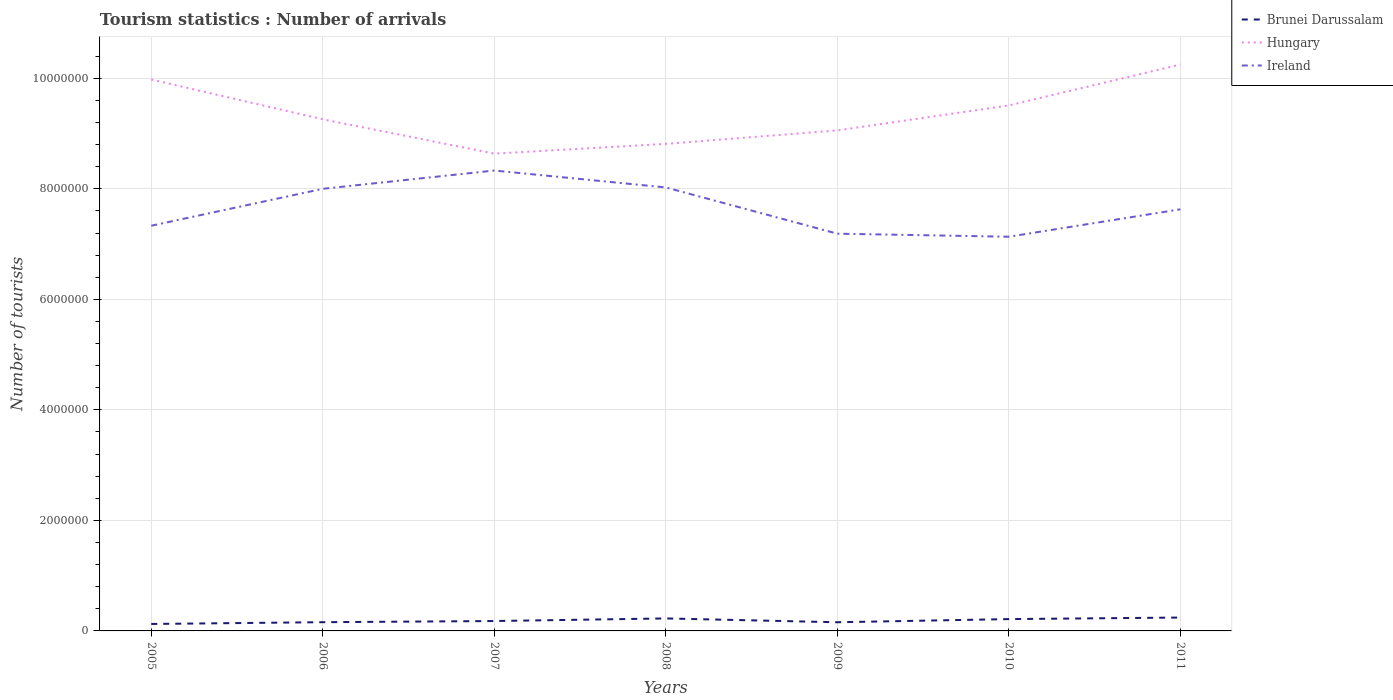Does the line corresponding to Ireland intersect with the line corresponding to Hungary?
Keep it short and to the point. No. Is the number of lines equal to the number of legend labels?
Make the answer very short. Yes. Across all years, what is the maximum number of tourist arrivals in Ireland?
Make the answer very short. 7.13e+06. What is the total number of tourist arrivals in Brunei Darussalam in the graph?
Provide a succinct answer. -1.00e+05. What is the difference between the highest and the second highest number of tourist arrivals in Brunei Darussalam?
Your answer should be very brief. 1.16e+05. What is the difference between the highest and the lowest number of tourist arrivals in Hungary?
Your answer should be very brief. 3. How many lines are there?
Ensure brevity in your answer.  3. What is the difference between two consecutive major ticks on the Y-axis?
Offer a very short reply. 2.00e+06. Does the graph contain any zero values?
Your answer should be very brief. No. Does the graph contain grids?
Give a very brief answer. Yes. Where does the legend appear in the graph?
Your response must be concise. Top right. How many legend labels are there?
Your answer should be very brief. 3. How are the legend labels stacked?
Your response must be concise. Vertical. What is the title of the graph?
Your response must be concise. Tourism statistics : Number of arrivals. What is the label or title of the Y-axis?
Offer a terse response. Number of tourists. What is the Number of tourists of Brunei Darussalam in 2005?
Offer a very short reply. 1.26e+05. What is the Number of tourists in Hungary in 2005?
Your answer should be very brief. 9.98e+06. What is the Number of tourists of Ireland in 2005?
Ensure brevity in your answer.  7.33e+06. What is the Number of tourists in Brunei Darussalam in 2006?
Your response must be concise. 1.58e+05. What is the Number of tourists of Hungary in 2006?
Your answer should be compact. 9.26e+06. What is the Number of tourists of Ireland in 2006?
Provide a short and direct response. 8.00e+06. What is the Number of tourists in Brunei Darussalam in 2007?
Provide a short and direct response. 1.79e+05. What is the Number of tourists of Hungary in 2007?
Ensure brevity in your answer.  8.64e+06. What is the Number of tourists of Ireland in 2007?
Provide a succinct answer. 8.33e+06. What is the Number of tourists of Brunei Darussalam in 2008?
Give a very brief answer. 2.26e+05. What is the Number of tourists in Hungary in 2008?
Keep it short and to the point. 8.81e+06. What is the Number of tourists in Ireland in 2008?
Provide a succinct answer. 8.03e+06. What is the Number of tourists in Brunei Darussalam in 2009?
Offer a very short reply. 1.57e+05. What is the Number of tourists of Hungary in 2009?
Make the answer very short. 9.06e+06. What is the Number of tourists of Ireland in 2009?
Make the answer very short. 7.19e+06. What is the Number of tourists of Brunei Darussalam in 2010?
Provide a short and direct response. 2.14e+05. What is the Number of tourists in Hungary in 2010?
Provide a succinct answer. 9.51e+06. What is the Number of tourists in Ireland in 2010?
Your answer should be compact. 7.13e+06. What is the Number of tourists in Brunei Darussalam in 2011?
Ensure brevity in your answer.  2.42e+05. What is the Number of tourists of Hungary in 2011?
Provide a short and direct response. 1.02e+07. What is the Number of tourists in Ireland in 2011?
Provide a succinct answer. 7.63e+06. Across all years, what is the maximum Number of tourists of Brunei Darussalam?
Keep it short and to the point. 2.42e+05. Across all years, what is the maximum Number of tourists in Hungary?
Ensure brevity in your answer.  1.02e+07. Across all years, what is the maximum Number of tourists of Ireland?
Ensure brevity in your answer.  8.33e+06. Across all years, what is the minimum Number of tourists of Brunei Darussalam?
Offer a terse response. 1.26e+05. Across all years, what is the minimum Number of tourists in Hungary?
Keep it short and to the point. 8.64e+06. Across all years, what is the minimum Number of tourists in Ireland?
Your response must be concise. 7.13e+06. What is the total Number of tourists in Brunei Darussalam in the graph?
Give a very brief answer. 1.30e+06. What is the total Number of tourists in Hungary in the graph?
Your answer should be compact. 6.55e+07. What is the total Number of tourists in Ireland in the graph?
Your response must be concise. 5.36e+07. What is the difference between the Number of tourists of Brunei Darussalam in 2005 and that in 2006?
Make the answer very short. -3.20e+04. What is the difference between the Number of tourists of Hungary in 2005 and that in 2006?
Provide a short and direct response. 7.20e+05. What is the difference between the Number of tourists in Ireland in 2005 and that in 2006?
Ensure brevity in your answer.  -6.68e+05. What is the difference between the Number of tourists of Brunei Darussalam in 2005 and that in 2007?
Offer a terse response. -5.30e+04. What is the difference between the Number of tourists of Hungary in 2005 and that in 2007?
Your answer should be very brief. 1.34e+06. What is the difference between the Number of tourists in Ireland in 2005 and that in 2007?
Make the answer very short. -9.99e+05. What is the difference between the Number of tourists of Brunei Darussalam in 2005 and that in 2008?
Give a very brief answer. -1.00e+05. What is the difference between the Number of tourists of Hungary in 2005 and that in 2008?
Your answer should be very brief. 1.16e+06. What is the difference between the Number of tourists of Ireland in 2005 and that in 2008?
Make the answer very short. -6.93e+05. What is the difference between the Number of tourists in Brunei Darussalam in 2005 and that in 2009?
Provide a succinct answer. -3.10e+04. What is the difference between the Number of tourists in Hungary in 2005 and that in 2009?
Your answer should be compact. 9.21e+05. What is the difference between the Number of tourists in Ireland in 2005 and that in 2009?
Offer a terse response. 1.44e+05. What is the difference between the Number of tourists in Brunei Darussalam in 2005 and that in 2010?
Give a very brief answer. -8.80e+04. What is the difference between the Number of tourists in Hungary in 2005 and that in 2010?
Your answer should be compact. 4.69e+05. What is the difference between the Number of tourists of Ireland in 2005 and that in 2010?
Your response must be concise. 1.99e+05. What is the difference between the Number of tourists in Brunei Darussalam in 2005 and that in 2011?
Ensure brevity in your answer.  -1.16e+05. What is the difference between the Number of tourists in Hungary in 2005 and that in 2011?
Ensure brevity in your answer.  -2.71e+05. What is the difference between the Number of tourists in Ireland in 2005 and that in 2011?
Ensure brevity in your answer.  -2.97e+05. What is the difference between the Number of tourists of Brunei Darussalam in 2006 and that in 2007?
Keep it short and to the point. -2.10e+04. What is the difference between the Number of tourists of Hungary in 2006 and that in 2007?
Keep it short and to the point. 6.21e+05. What is the difference between the Number of tourists of Ireland in 2006 and that in 2007?
Keep it short and to the point. -3.31e+05. What is the difference between the Number of tourists in Brunei Darussalam in 2006 and that in 2008?
Offer a terse response. -6.80e+04. What is the difference between the Number of tourists of Hungary in 2006 and that in 2008?
Your answer should be compact. 4.45e+05. What is the difference between the Number of tourists in Ireland in 2006 and that in 2008?
Provide a succinct answer. -2.50e+04. What is the difference between the Number of tourists in Brunei Darussalam in 2006 and that in 2009?
Keep it short and to the point. 1000. What is the difference between the Number of tourists in Hungary in 2006 and that in 2009?
Keep it short and to the point. 2.01e+05. What is the difference between the Number of tourists of Ireland in 2006 and that in 2009?
Offer a terse response. 8.12e+05. What is the difference between the Number of tourists in Brunei Darussalam in 2006 and that in 2010?
Make the answer very short. -5.60e+04. What is the difference between the Number of tourists of Hungary in 2006 and that in 2010?
Give a very brief answer. -2.51e+05. What is the difference between the Number of tourists of Ireland in 2006 and that in 2010?
Ensure brevity in your answer.  8.67e+05. What is the difference between the Number of tourists in Brunei Darussalam in 2006 and that in 2011?
Give a very brief answer. -8.40e+04. What is the difference between the Number of tourists of Hungary in 2006 and that in 2011?
Your answer should be compact. -9.91e+05. What is the difference between the Number of tourists in Ireland in 2006 and that in 2011?
Give a very brief answer. 3.71e+05. What is the difference between the Number of tourists of Brunei Darussalam in 2007 and that in 2008?
Provide a succinct answer. -4.70e+04. What is the difference between the Number of tourists of Hungary in 2007 and that in 2008?
Keep it short and to the point. -1.76e+05. What is the difference between the Number of tourists in Ireland in 2007 and that in 2008?
Provide a succinct answer. 3.06e+05. What is the difference between the Number of tourists of Brunei Darussalam in 2007 and that in 2009?
Ensure brevity in your answer.  2.20e+04. What is the difference between the Number of tourists in Hungary in 2007 and that in 2009?
Offer a terse response. -4.20e+05. What is the difference between the Number of tourists of Ireland in 2007 and that in 2009?
Offer a very short reply. 1.14e+06. What is the difference between the Number of tourists of Brunei Darussalam in 2007 and that in 2010?
Provide a succinct answer. -3.50e+04. What is the difference between the Number of tourists in Hungary in 2007 and that in 2010?
Your response must be concise. -8.72e+05. What is the difference between the Number of tourists in Ireland in 2007 and that in 2010?
Keep it short and to the point. 1.20e+06. What is the difference between the Number of tourists in Brunei Darussalam in 2007 and that in 2011?
Make the answer very short. -6.30e+04. What is the difference between the Number of tourists in Hungary in 2007 and that in 2011?
Your answer should be very brief. -1.61e+06. What is the difference between the Number of tourists in Ireland in 2007 and that in 2011?
Keep it short and to the point. 7.02e+05. What is the difference between the Number of tourists in Brunei Darussalam in 2008 and that in 2009?
Keep it short and to the point. 6.90e+04. What is the difference between the Number of tourists in Hungary in 2008 and that in 2009?
Make the answer very short. -2.44e+05. What is the difference between the Number of tourists of Ireland in 2008 and that in 2009?
Your response must be concise. 8.37e+05. What is the difference between the Number of tourists in Brunei Darussalam in 2008 and that in 2010?
Your answer should be very brief. 1.20e+04. What is the difference between the Number of tourists in Hungary in 2008 and that in 2010?
Provide a short and direct response. -6.96e+05. What is the difference between the Number of tourists in Ireland in 2008 and that in 2010?
Offer a very short reply. 8.92e+05. What is the difference between the Number of tourists of Brunei Darussalam in 2008 and that in 2011?
Ensure brevity in your answer.  -1.60e+04. What is the difference between the Number of tourists in Hungary in 2008 and that in 2011?
Provide a short and direct response. -1.44e+06. What is the difference between the Number of tourists in Ireland in 2008 and that in 2011?
Ensure brevity in your answer.  3.96e+05. What is the difference between the Number of tourists in Brunei Darussalam in 2009 and that in 2010?
Give a very brief answer. -5.70e+04. What is the difference between the Number of tourists in Hungary in 2009 and that in 2010?
Provide a succinct answer. -4.52e+05. What is the difference between the Number of tourists of Ireland in 2009 and that in 2010?
Provide a succinct answer. 5.50e+04. What is the difference between the Number of tourists in Brunei Darussalam in 2009 and that in 2011?
Keep it short and to the point. -8.50e+04. What is the difference between the Number of tourists in Hungary in 2009 and that in 2011?
Provide a succinct answer. -1.19e+06. What is the difference between the Number of tourists in Ireland in 2009 and that in 2011?
Your answer should be very brief. -4.41e+05. What is the difference between the Number of tourists of Brunei Darussalam in 2010 and that in 2011?
Ensure brevity in your answer.  -2.80e+04. What is the difference between the Number of tourists of Hungary in 2010 and that in 2011?
Make the answer very short. -7.40e+05. What is the difference between the Number of tourists in Ireland in 2010 and that in 2011?
Your answer should be very brief. -4.96e+05. What is the difference between the Number of tourists of Brunei Darussalam in 2005 and the Number of tourists of Hungary in 2006?
Provide a short and direct response. -9.13e+06. What is the difference between the Number of tourists in Brunei Darussalam in 2005 and the Number of tourists in Ireland in 2006?
Offer a terse response. -7.88e+06. What is the difference between the Number of tourists of Hungary in 2005 and the Number of tourists of Ireland in 2006?
Your response must be concise. 1.98e+06. What is the difference between the Number of tourists in Brunei Darussalam in 2005 and the Number of tourists in Hungary in 2007?
Offer a very short reply. -8.51e+06. What is the difference between the Number of tourists in Brunei Darussalam in 2005 and the Number of tourists in Ireland in 2007?
Ensure brevity in your answer.  -8.21e+06. What is the difference between the Number of tourists in Hungary in 2005 and the Number of tourists in Ireland in 2007?
Provide a short and direct response. 1.65e+06. What is the difference between the Number of tourists in Brunei Darussalam in 2005 and the Number of tourists in Hungary in 2008?
Keep it short and to the point. -8.69e+06. What is the difference between the Number of tourists of Brunei Darussalam in 2005 and the Number of tourists of Ireland in 2008?
Your response must be concise. -7.90e+06. What is the difference between the Number of tourists in Hungary in 2005 and the Number of tourists in Ireland in 2008?
Make the answer very short. 1.95e+06. What is the difference between the Number of tourists in Brunei Darussalam in 2005 and the Number of tourists in Hungary in 2009?
Provide a succinct answer. -8.93e+06. What is the difference between the Number of tourists in Brunei Darussalam in 2005 and the Number of tourists in Ireland in 2009?
Your response must be concise. -7.06e+06. What is the difference between the Number of tourists of Hungary in 2005 and the Number of tourists of Ireland in 2009?
Keep it short and to the point. 2.79e+06. What is the difference between the Number of tourists of Brunei Darussalam in 2005 and the Number of tourists of Hungary in 2010?
Make the answer very short. -9.38e+06. What is the difference between the Number of tourists in Brunei Darussalam in 2005 and the Number of tourists in Ireland in 2010?
Make the answer very short. -7.01e+06. What is the difference between the Number of tourists in Hungary in 2005 and the Number of tourists in Ireland in 2010?
Provide a succinct answer. 2.84e+06. What is the difference between the Number of tourists in Brunei Darussalam in 2005 and the Number of tourists in Hungary in 2011?
Your response must be concise. -1.01e+07. What is the difference between the Number of tourists of Brunei Darussalam in 2005 and the Number of tourists of Ireland in 2011?
Offer a very short reply. -7.50e+06. What is the difference between the Number of tourists of Hungary in 2005 and the Number of tourists of Ireland in 2011?
Your response must be concise. 2.35e+06. What is the difference between the Number of tourists in Brunei Darussalam in 2006 and the Number of tourists in Hungary in 2007?
Keep it short and to the point. -8.48e+06. What is the difference between the Number of tourists in Brunei Darussalam in 2006 and the Number of tourists in Ireland in 2007?
Give a very brief answer. -8.17e+06. What is the difference between the Number of tourists in Hungary in 2006 and the Number of tourists in Ireland in 2007?
Provide a succinct answer. 9.27e+05. What is the difference between the Number of tourists in Brunei Darussalam in 2006 and the Number of tourists in Hungary in 2008?
Offer a very short reply. -8.66e+06. What is the difference between the Number of tourists in Brunei Darussalam in 2006 and the Number of tourists in Ireland in 2008?
Your response must be concise. -7.87e+06. What is the difference between the Number of tourists of Hungary in 2006 and the Number of tourists of Ireland in 2008?
Give a very brief answer. 1.23e+06. What is the difference between the Number of tourists of Brunei Darussalam in 2006 and the Number of tourists of Hungary in 2009?
Offer a terse response. -8.90e+06. What is the difference between the Number of tourists of Brunei Darussalam in 2006 and the Number of tourists of Ireland in 2009?
Offer a very short reply. -7.03e+06. What is the difference between the Number of tourists of Hungary in 2006 and the Number of tourists of Ireland in 2009?
Offer a terse response. 2.07e+06. What is the difference between the Number of tourists in Brunei Darussalam in 2006 and the Number of tourists in Hungary in 2010?
Provide a short and direct response. -9.35e+06. What is the difference between the Number of tourists in Brunei Darussalam in 2006 and the Number of tourists in Ireland in 2010?
Your answer should be compact. -6.98e+06. What is the difference between the Number of tourists in Hungary in 2006 and the Number of tourists in Ireland in 2010?
Provide a succinct answer. 2.12e+06. What is the difference between the Number of tourists in Brunei Darussalam in 2006 and the Number of tourists in Hungary in 2011?
Give a very brief answer. -1.01e+07. What is the difference between the Number of tourists in Brunei Darussalam in 2006 and the Number of tourists in Ireland in 2011?
Your answer should be compact. -7.47e+06. What is the difference between the Number of tourists of Hungary in 2006 and the Number of tourists of Ireland in 2011?
Ensure brevity in your answer.  1.63e+06. What is the difference between the Number of tourists of Brunei Darussalam in 2007 and the Number of tourists of Hungary in 2008?
Keep it short and to the point. -8.64e+06. What is the difference between the Number of tourists of Brunei Darussalam in 2007 and the Number of tourists of Ireland in 2008?
Ensure brevity in your answer.  -7.85e+06. What is the difference between the Number of tourists in Hungary in 2007 and the Number of tourists in Ireland in 2008?
Ensure brevity in your answer.  6.12e+05. What is the difference between the Number of tourists of Brunei Darussalam in 2007 and the Number of tourists of Hungary in 2009?
Your answer should be compact. -8.88e+06. What is the difference between the Number of tourists in Brunei Darussalam in 2007 and the Number of tourists in Ireland in 2009?
Provide a short and direct response. -7.01e+06. What is the difference between the Number of tourists of Hungary in 2007 and the Number of tourists of Ireland in 2009?
Provide a succinct answer. 1.45e+06. What is the difference between the Number of tourists of Brunei Darussalam in 2007 and the Number of tourists of Hungary in 2010?
Provide a succinct answer. -9.33e+06. What is the difference between the Number of tourists of Brunei Darussalam in 2007 and the Number of tourists of Ireland in 2010?
Provide a succinct answer. -6.96e+06. What is the difference between the Number of tourists of Hungary in 2007 and the Number of tourists of Ireland in 2010?
Ensure brevity in your answer.  1.50e+06. What is the difference between the Number of tourists of Brunei Darussalam in 2007 and the Number of tourists of Hungary in 2011?
Ensure brevity in your answer.  -1.01e+07. What is the difference between the Number of tourists of Brunei Darussalam in 2007 and the Number of tourists of Ireland in 2011?
Your response must be concise. -7.45e+06. What is the difference between the Number of tourists in Hungary in 2007 and the Number of tourists in Ireland in 2011?
Offer a very short reply. 1.01e+06. What is the difference between the Number of tourists of Brunei Darussalam in 2008 and the Number of tourists of Hungary in 2009?
Offer a very short reply. -8.83e+06. What is the difference between the Number of tourists of Brunei Darussalam in 2008 and the Number of tourists of Ireland in 2009?
Make the answer very short. -6.96e+06. What is the difference between the Number of tourists of Hungary in 2008 and the Number of tourists of Ireland in 2009?
Ensure brevity in your answer.  1.62e+06. What is the difference between the Number of tourists in Brunei Darussalam in 2008 and the Number of tourists in Hungary in 2010?
Offer a very short reply. -9.28e+06. What is the difference between the Number of tourists of Brunei Darussalam in 2008 and the Number of tourists of Ireland in 2010?
Give a very brief answer. -6.91e+06. What is the difference between the Number of tourists in Hungary in 2008 and the Number of tourists in Ireland in 2010?
Offer a very short reply. 1.68e+06. What is the difference between the Number of tourists of Brunei Darussalam in 2008 and the Number of tourists of Hungary in 2011?
Ensure brevity in your answer.  -1.00e+07. What is the difference between the Number of tourists of Brunei Darussalam in 2008 and the Number of tourists of Ireland in 2011?
Your answer should be very brief. -7.40e+06. What is the difference between the Number of tourists in Hungary in 2008 and the Number of tourists in Ireland in 2011?
Keep it short and to the point. 1.18e+06. What is the difference between the Number of tourists of Brunei Darussalam in 2009 and the Number of tourists of Hungary in 2010?
Give a very brief answer. -9.35e+06. What is the difference between the Number of tourists of Brunei Darussalam in 2009 and the Number of tourists of Ireland in 2010?
Offer a terse response. -6.98e+06. What is the difference between the Number of tourists of Hungary in 2009 and the Number of tourists of Ireland in 2010?
Your response must be concise. 1.92e+06. What is the difference between the Number of tourists in Brunei Darussalam in 2009 and the Number of tourists in Hungary in 2011?
Your answer should be very brief. -1.01e+07. What is the difference between the Number of tourists in Brunei Darussalam in 2009 and the Number of tourists in Ireland in 2011?
Your answer should be compact. -7.47e+06. What is the difference between the Number of tourists of Hungary in 2009 and the Number of tourists of Ireland in 2011?
Your answer should be compact. 1.43e+06. What is the difference between the Number of tourists of Brunei Darussalam in 2010 and the Number of tourists of Hungary in 2011?
Provide a succinct answer. -1.00e+07. What is the difference between the Number of tourists of Brunei Darussalam in 2010 and the Number of tourists of Ireland in 2011?
Keep it short and to the point. -7.42e+06. What is the difference between the Number of tourists in Hungary in 2010 and the Number of tourists in Ireland in 2011?
Keep it short and to the point. 1.88e+06. What is the average Number of tourists in Brunei Darussalam per year?
Your answer should be compact. 1.86e+05. What is the average Number of tourists in Hungary per year?
Make the answer very short. 9.36e+06. What is the average Number of tourists of Ireland per year?
Give a very brief answer. 7.66e+06. In the year 2005, what is the difference between the Number of tourists in Brunei Darussalam and Number of tourists in Hungary?
Keep it short and to the point. -9.85e+06. In the year 2005, what is the difference between the Number of tourists of Brunei Darussalam and Number of tourists of Ireland?
Make the answer very short. -7.21e+06. In the year 2005, what is the difference between the Number of tourists in Hungary and Number of tourists in Ireland?
Offer a terse response. 2.65e+06. In the year 2006, what is the difference between the Number of tourists in Brunei Darussalam and Number of tourists in Hungary?
Your answer should be very brief. -9.10e+06. In the year 2006, what is the difference between the Number of tourists of Brunei Darussalam and Number of tourists of Ireland?
Offer a terse response. -7.84e+06. In the year 2006, what is the difference between the Number of tourists of Hungary and Number of tourists of Ireland?
Provide a succinct answer. 1.26e+06. In the year 2007, what is the difference between the Number of tourists in Brunei Darussalam and Number of tourists in Hungary?
Your answer should be very brief. -8.46e+06. In the year 2007, what is the difference between the Number of tourists of Brunei Darussalam and Number of tourists of Ireland?
Provide a succinct answer. -8.15e+06. In the year 2007, what is the difference between the Number of tourists of Hungary and Number of tourists of Ireland?
Offer a terse response. 3.06e+05. In the year 2008, what is the difference between the Number of tourists of Brunei Darussalam and Number of tourists of Hungary?
Keep it short and to the point. -8.59e+06. In the year 2008, what is the difference between the Number of tourists of Brunei Darussalam and Number of tourists of Ireland?
Offer a terse response. -7.80e+06. In the year 2008, what is the difference between the Number of tourists in Hungary and Number of tourists in Ireland?
Your response must be concise. 7.88e+05. In the year 2009, what is the difference between the Number of tourists in Brunei Darussalam and Number of tourists in Hungary?
Your response must be concise. -8.90e+06. In the year 2009, what is the difference between the Number of tourists of Brunei Darussalam and Number of tourists of Ireland?
Offer a very short reply. -7.03e+06. In the year 2009, what is the difference between the Number of tourists of Hungary and Number of tourists of Ireland?
Make the answer very short. 1.87e+06. In the year 2010, what is the difference between the Number of tourists of Brunei Darussalam and Number of tourists of Hungary?
Ensure brevity in your answer.  -9.30e+06. In the year 2010, what is the difference between the Number of tourists in Brunei Darussalam and Number of tourists in Ireland?
Your answer should be compact. -6.92e+06. In the year 2010, what is the difference between the Number of tourists in Hungary and Number of tourists in Ireland?
Offer a terse response. 2.38e+06. In the year 2011, what is the difference between the Number of tourists in Brunei Darussalam and Number of tourists in Hungary?
Provide a succinct answer. -1.00e+07. In the year 2011, what is the difference between the Number of tourists in Brunei Darussalam and Number of tourists in Ireland?
Make the answer very short. -7.39e+06. In the year 2011, what is the difference between the Number of tourists of Hungary and Number of tourists of Ireland?
Your answer should be compact. 2.62e+06. What is the ratio of the Number of tourists in Brunei Darussalam in 2005 to that in 2006?
Your answer should be compact. 0.8. What is the ratio of the Number of tourists in Hungary in 2005 to that in 2006?
Your answer should be compact. 1.08. What is the ratio of the Number of tourists of Ireland in 2005 to that in 2006?
Your answer should be compact. 0.92. What is the ratio of the Number of tourists of Brunei Darussalam in 2005 to that in 2007?
Provide a succinct answer. 0.7. What is the ratio of the Number of tourists in Hungary in 2005 to that in 2007?
Your answer should be very brief. 1.16. What is the ratio of the Number of tourists of Ireland in 2005 to that in 2007?
Your response must be concise. 0.88. What is the ratio of the Number of tourists in Brunei Darussalam in 2005 to that in 2008?
Provide a short and direct response. 0.56. What is the ratio of the Number of tourists of Hungary in 2005 to that in 2008?
Your answer should be very brief. 1.13. What is the ratio of the Number of tourists of Ireland in 2005 to that in 2008?
Offer a very short reply. 0.91. What is the ratio of the Number of tourists of Brunei Darussalam in 2005 to that in 2009?
Provide a succinct answer. 0.8. What is the ratio of the Number of tourists of Hungary in 2005 to that in 2009?
Provide a succinct answer. 1.1. What is the ratio of the Number of tourists of Ireland in 2005 to that in 2009?
Provide a succinct answer. 1.02. What is the ratio of the Number of tourists of Brunei Darussalam in 2005 to that in 2010?
Provide a succinct answer. 0.59. What is the ratio of the Number of tourists of Hungary in 2005 to that in 2010?
Offer a terse response. 1.05. What is the ratio of the Number of tourists in Ireland in 2005 to that in 2010?
Offer a terse response. 1.03. What is the ratio of the Number of tourists of Brunei Darussalam in 2005 to that in 2011?
Provide a succinct answer. 0.52. What is the ratio of the Number of tourists in Hungary in 2005 to that in 2011?
Provide a succinct answer. 0.97. What is the ratio of the Number of tourists of Ireland in 2005 to that in 2011?
Provide a short and direct response. 0.96. What is the ratio of the Number of tourists of Brunei Darussalam in 2006 to that in 2007?
Your response must be concise. 0.88. What is the ratio of the Number of tourists of Hungary in 2006 to that in 2007?
Your response must be concise. 1.07. What is the ratio of the Number of tourists of Ireland in 2006 to that in 2007?
Give a very brief answer. 0.96. What is the ratio of the Number of tourists of Brunei Darussalam in 2006 to that in 2008?
Your response must be concise. 0.7. What is the ratio of the Number of tourists in Hungary in 2006 to that in 2008?
Ensure brevity in your answer.  1.05. What is the ratio of the Number of tourists in Ireland in 2006 to that in 2008?
Provide a succinct answer. 1. What is the ratio of the Number of tourists in Brunei Darussalam in 2006 to that in 2009?
Keep it short and to the point. 1.01. What is the ratio of the Number of tourists in Hungary in 2006 to that in 2009?
Offer a very short reply. 1.02. What is the ratio of the Number of tourists in Ireland in 2006 to that in 2009?
Your answer should be very brief. 1.11. What is the ratio of the Number of tourists of Brunei Darussalam in 2006 to that in 2010?
Your response must be concise. 0.74. What is the ratio of the Number of tourists in Hungary in 2006 to that in 2010?
Make the answer very short. 0.97. What is the ratio of the Number of tourists in Ireland in 2006 to that in 2010?
Your answer should be compact. 1.12. What is the ratio of the Number of tourists of Brunei Darussalam in 2006 to that in 2011?
Your answer should be very brief. 0.65. What is the ratio of the Number of tourists of Hungary in 2006 to that in 2011?
Ensure brevity in your answer.  0.9. What is the ratio of the Number of tourists in Ireland in 2006 to that in 2011?
Offer a very short reply. 1.05. What is the ratio of the Number of tourists in Brunei Darussalam in 2007 to that in 2008?
Keep it short and to the point. 0.79. What is the ratio of the Number of tourists in Ireland in 2007 to that in 2008?
Provide a short and direct response. 1.04. What is the ratio of the Number of tourists of Brunei Darussalam in 2007 to that in 2009?
Provide a succinct answer. 1.14. What is the ratio of the Number of tourists in Hungary in 2007 to that in 2009?
Your answer should be very brief. 0.95. What is the ratio of the Number of tourists of Ireland in 2007 to that in 2009?
Give a very brief answer. 1.16. What is the ratio of the Number of tourists of Brunei Darussalam in 2007 to that in 2010?
Your answer should be very brief. 0.84. What is the ratio of the Number of tourists in Hungary in 2007 to that in 2010?
Your response must be concise. 0.91. What is the ratio of the Number of tourists in Ireland in 2007 to that in 2010?
Your answer should be very brief. 1.17. What is the ratio of the Number of tourists in Brunei Darussalam in 2007 to that in 2011?
Give a very brief answer. 0.74. What is the ratio of the Number of tourists in Hungary in 2007 to that in 2011?
Keep it short and to the point. 0.84. What is the ratio of the Number of tourists in Ireland in 2007 to that in 2011?
Make the answer very short. 1.09. What is the ratio of the Number of tourists in Brunei Darussalam in 2008 to that in 2009?
Provide a succinct answer. 1.44. What is the ratio of the Number of tourists in Hungary in 2008 to that in 2009?
Give a very brief answer. 0.97. What is the ratio of the Number of tourists in Ireland in 2008 to that in 2009?
Ensure brevity in your answer.  1.12. What is the ratio of the Number of tourists of Brunei Darussalam in 2008 to that in 2010?
Provide a short and direct response. 1.06. What is the ratio of the Number of tourists in Hungary in 2008 to that in 2010?
Provide a short and direct response. 0.93. What is the ratio of the Number of tourists of Ireland in 2008 to that in 2010?
Provide a succinct answer. 1.12. What is the ratio of the Number of tourists of Brunei Darussalam in 2008 to that in 2011?
Keep it short and to the point. 0.93. What is the ratio of the Number of tourists in Hungary in 2008 to that in 2011?
Your response must be concise. 0.86. What is the ratio of the Number of tourists in Ireland in 2008 to that in 2011?
Ensure brevity in your answer.  1.05. What is the ratio of the Number of tourists in Brunei Darussalam in 2009 to that in 2010?
Your answer should be very brief. 0.73. What is the ratio of the Number of tourists in Hungary in 2009 to that in 2010?
Give a very brief answer. 0.95. What is the ratio of the Number of tourists of Ireland in 2009 to that in 2010?
Ensure brevity in your answer.  1.01. What is the ratio of the Number of tourists in Brunei Darussalam in 2009 to that in 2011?
Your response must be concise. 0.65. What is the ratio of the Number of tourists of Hungary in 2009 to that in 2011?
Provide a succinct answer. 0.88. What is the ratio of the Number of tourists of Ireland in 2009 to that in 2011?
Give a very brief answer. 0.94. What is the ratio of the Number of tourists in Brunei Darussalam in 2010 to that in 2011?
Your answer should be compact. 0.88. What is the ratio of the Number of tourists of Hungary in 2010 to that in 2011?
Provide a short and direct response. 0.93. What is the ratio of the Number of tourists of Ireland in 2010 to that in 2011?
Offer a terse response. 0.94. What is the difference between the highest and the second highest Number of tourists in Brunei Darussalam?
Your response must be concise. 1.60e+04. What is the difference between the highest and the second highest Number of tourists in Hungary?
Offer a very short reply. 2.71e+05. What is the difference between the highest and the second highest Number of tourists of Ireland?
Offer a terse response. 3.06e+05. What is the difference between the highest and the lowest Number of tourists in Brunei Darussalam?
Ensure brevity in your answer.  1.16e+05. What is the difference between the highest and the lowest Number of tourists of Hungary?
Your response must be concise. 1.61e+06. What is the difference between the highest and the lowest Number of tourists in Ireland?
Offer a very short reply. 1.20e+06. 